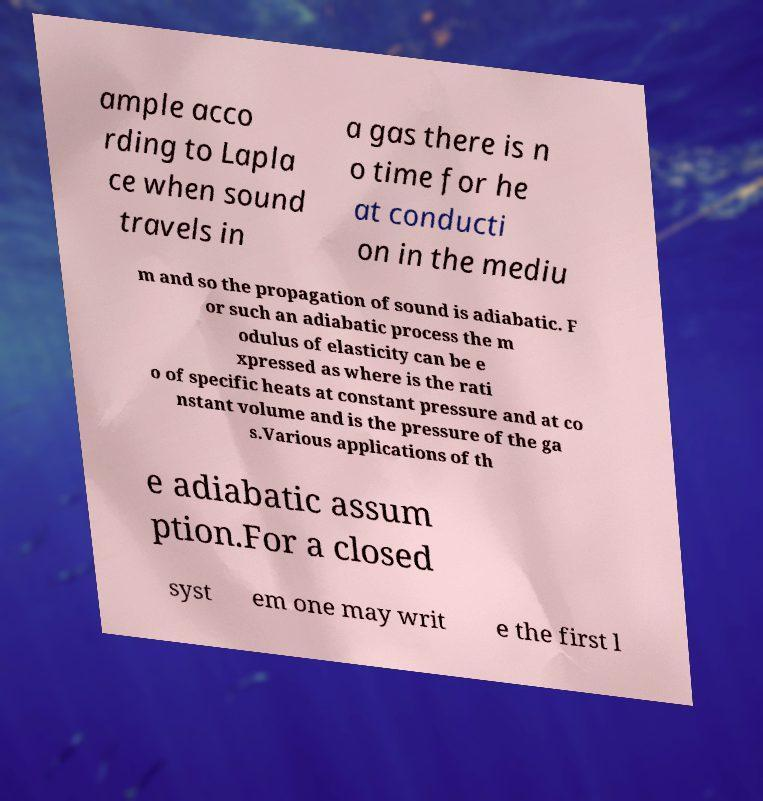I need the written content from this picture converted into text. Can you do that? ample acco rding to Lapla ce when sound travels in a gas there is n o time for he at conducti on in the mediu m and so the propagation of sound is adiabatic. F or such an adiabatic process the m odulus of elasticity can be e xpressed as where is the rati o of specific heats at constant pressure and at co nstant volume and is the pressure of the ga s.Various applications of th e adiabatic assum ption.For a closed syst em one may writ e the first l 